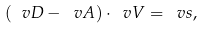Convert formula to latex. <formula><loc_0><loc_0><loc_500><loc_500>( \ v D - \ v A ) \cdot \ v V = \ v s ,</formula> 